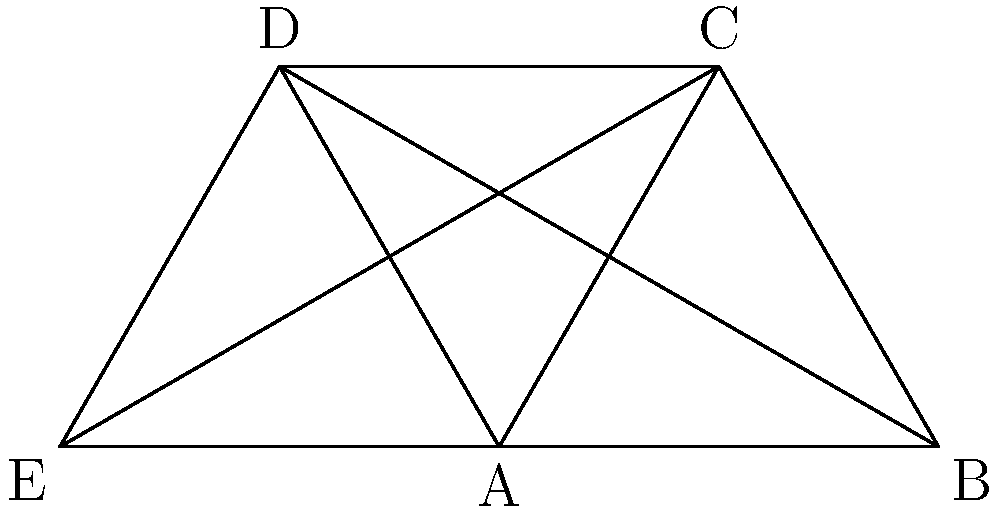As a visual storyteller working on an independent film project, you need to optimize the color composition of a complex scene. The scene contains five key elements represented by the vertices A, B, C, D, and E in the graph above. Each element needs to be assigned a distinct color, and adjacent elements should have contrasting colors. Given that you have three primary colors (red, blue, yellow) and their complementary colors (cyan, magenta, green) available, what is the minimum number of colors needed to properly color this graph? To solve this problem, we need to apply the concept of graph coloring:

1. First, observe that the graph is a complete graph K5, where every vertex is connected to every other vertex.

2. In graph theory, the chromatic number of a complete graph Kn is always n, meaning we need as many colors as there are vertices.

3. This is because in a complete graph, every vertex is adjacent to every other vertex, so each vertex must have a unique color.

4. In our case, we have 5 vertices (A, B, C, D, E), so we need at least 5 distinct colors.

5. The question provides us with 6 colors: red, blue, yellow, cyan, magenta, and green.

6. Since we have 6 colors available and we need at least 5 colors, we can conclude that 5 colors from our available set will be sufficient to properly color the graph.

7. This coloring ensures that no two adjacent vertices (elements in the scene) have the same color, optimizing the contrast between key elements in the composition.
Answer: 5 colors 